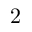<formula> <loc_0><loc_0><loc_500><loc_500>2</formula> 